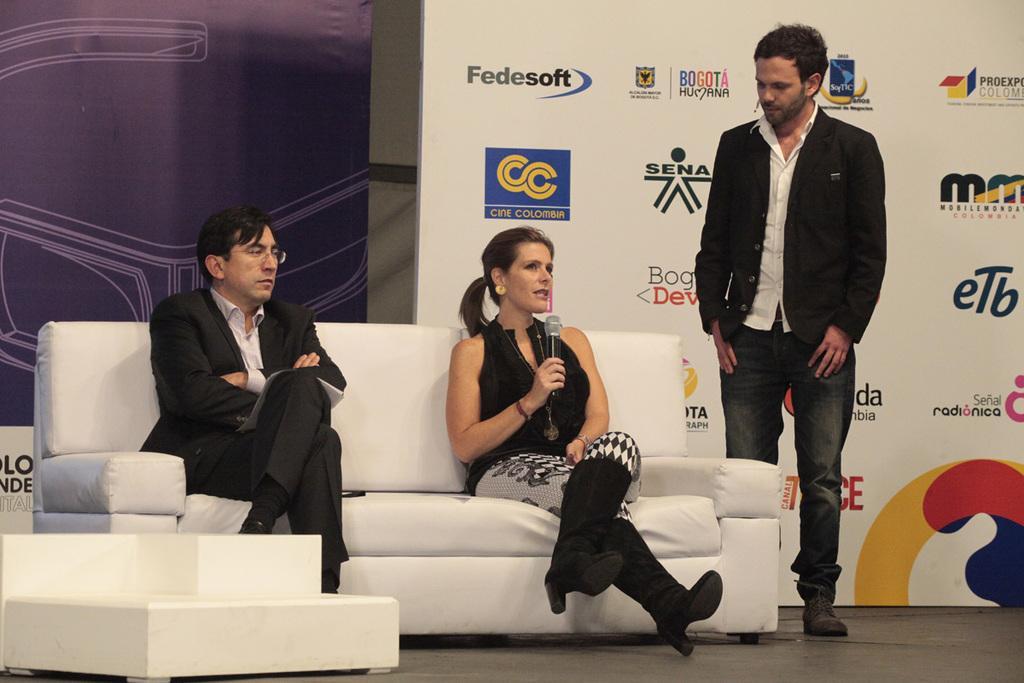In one or two sentences, can you explain what this image depicts? In this picture we can see two persons are sitting on the sofa. He has spectacles and she is holding a mike with her hand. Here we can see a man who is standing on the floor. On the background there is a hoarding. 